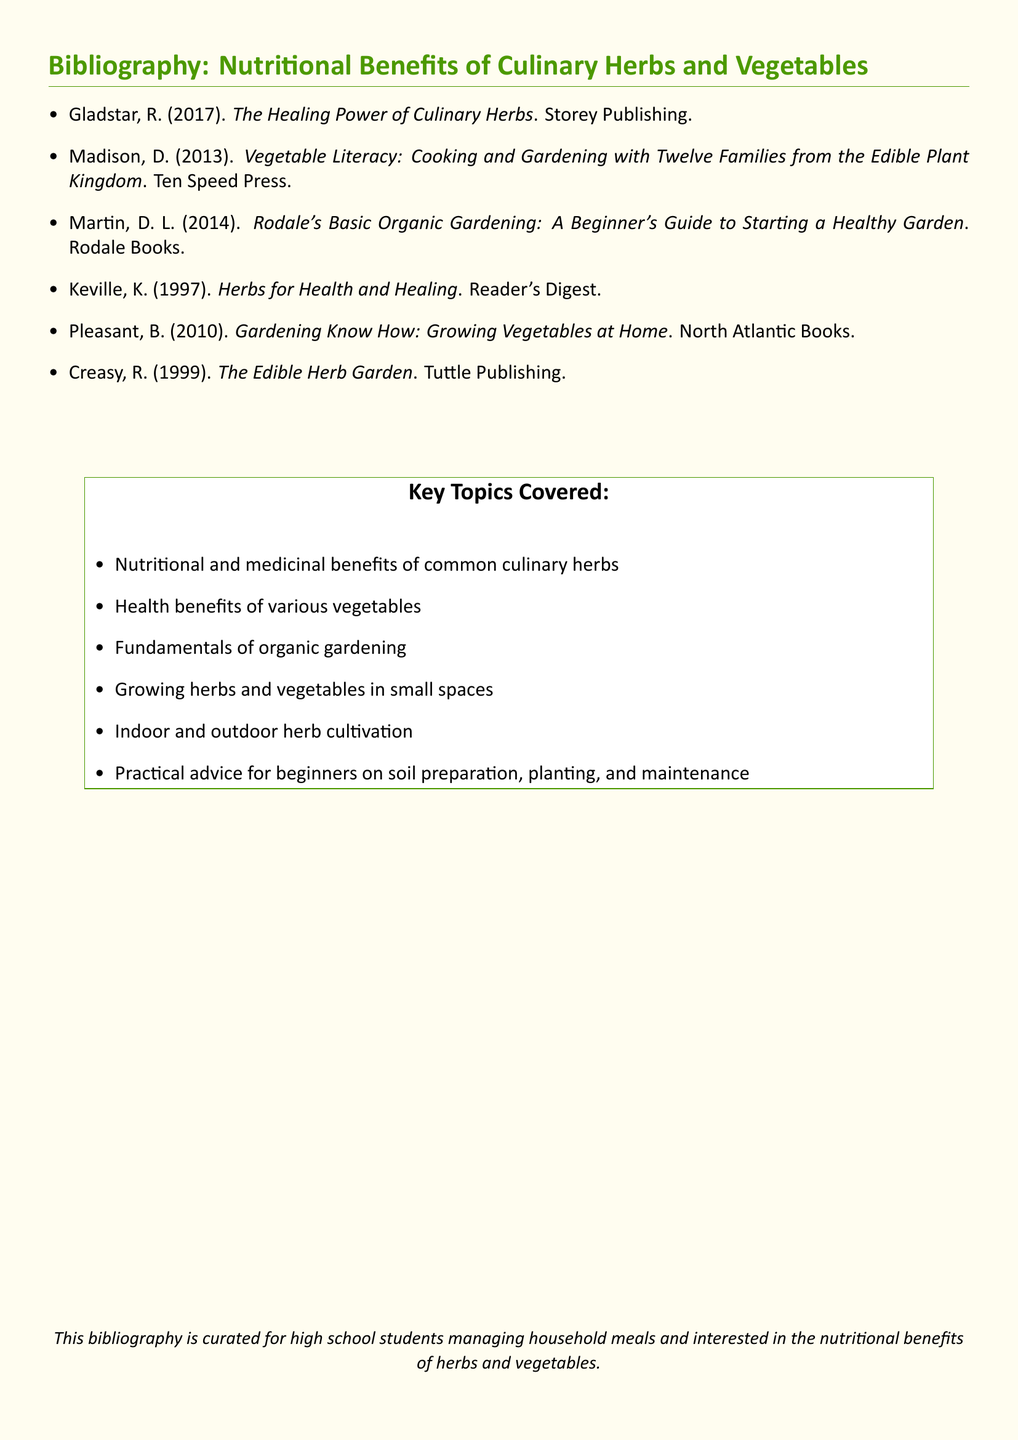What is the title of the bibliography? The title is found at the beginning of the document, summarizing the content about culinary herbs and vegetables.
Answer: Nutritional Benefits of Culinary Herbs and Vegetables Who authored "The Healing Power of Culinary Herbs"? The author of this book is listed in the bibliography section along with its publication year.
Answer: Gladstar In what year was "Vegetable Literacy" published? The publication year can be found next to the title in the bibliography list.
Answer: 2013 What type of gardening does Martin's book focus on? The document specifies the subject of the book in the title, which indicates its main focus.
Answer: Organic gardening Which publisher released "Herbs for Health and Healing"? The publisher's name is provided in parentheses following the book title in the bibliography.
Answer: Reader's Digest How many key topics are covered in the document? The number of key topics is derived from the list that follows the key topics heading.
Answer: Six What does the bibliography aim to assist high school students with? The intended audience and purpose are succinctly expressed in the last statement of the document.
Answer: Managing household meals What kind of cultivation does the document mention for herbs? The document includes specific details about cultivation methods for herbs found in the key topics list.
Answer: Indoor and outdoor herb cultivation 